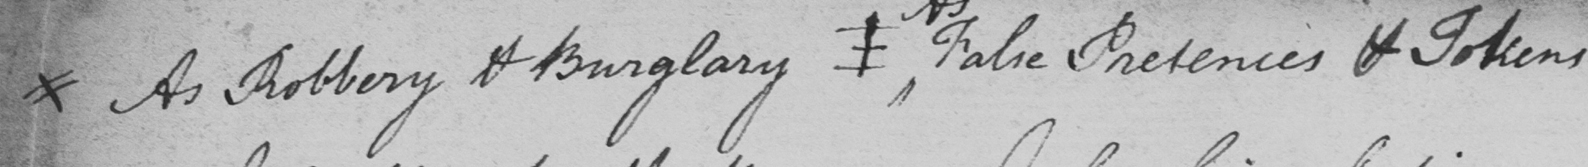Please transcribe the handwritten text in this image. xx As Robbery & Burglary  ⊥ False Pretences & Tokens 